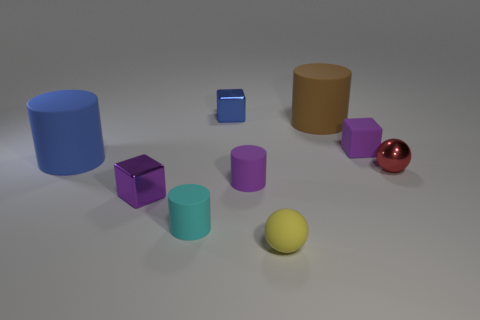There is a red object that is the same size as the purple cylinder; what material is it?
Keep it short and to the point. Metal. What number of other objects are there of the same material as the red ball?
Your answer should be compact. 2. Is the color of the ball on the left side of the large brown matte thing the same as the cube in front of the shiny sphere?
Offer a terse response. No. The object that is left of the tiny shiny object that is in front of the tiny red sphere is what shape?
Your response must be concise. Cylinder. How many other objects are there of the same color as the small matte cube?
Provide a succinct answer. 2. Is the purple block behind the tiny purple cylinder made of the same material as the cylinder that is in front of the tiny purple metal cube?
Keep it short and to the point. Yes. What size is the object on the left side of the tiny purple metal block?
Offer a terse response. Large. There is a tiny purple thing that is the same shape as the brown rubber thing; what is it made of?
Make the answer very short. Rubber. Is there any other thing that has the same size as the purple metal block?
Offer a very short reply. Yes. There is a tiny purple matte thing that is in front of the small red metallic sphere; what is its shape?
Offer a terse response. Cylinder. 